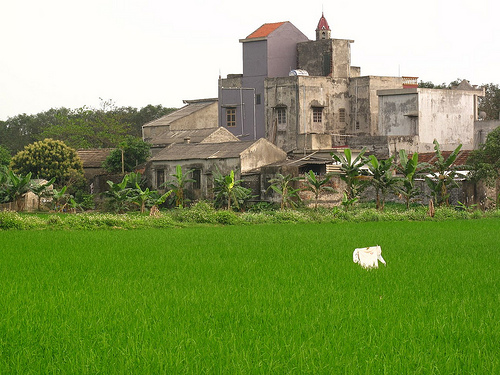<image>
Is there a tree in front of the grass? No. The tree is not in front of the grass. The spatial positioning shows a different relationship between these objects. 